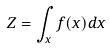<formula> <loc_0><loc_0><loc_500><loc_500>Z = \int _ { x } f ( x ) d x</formula> 